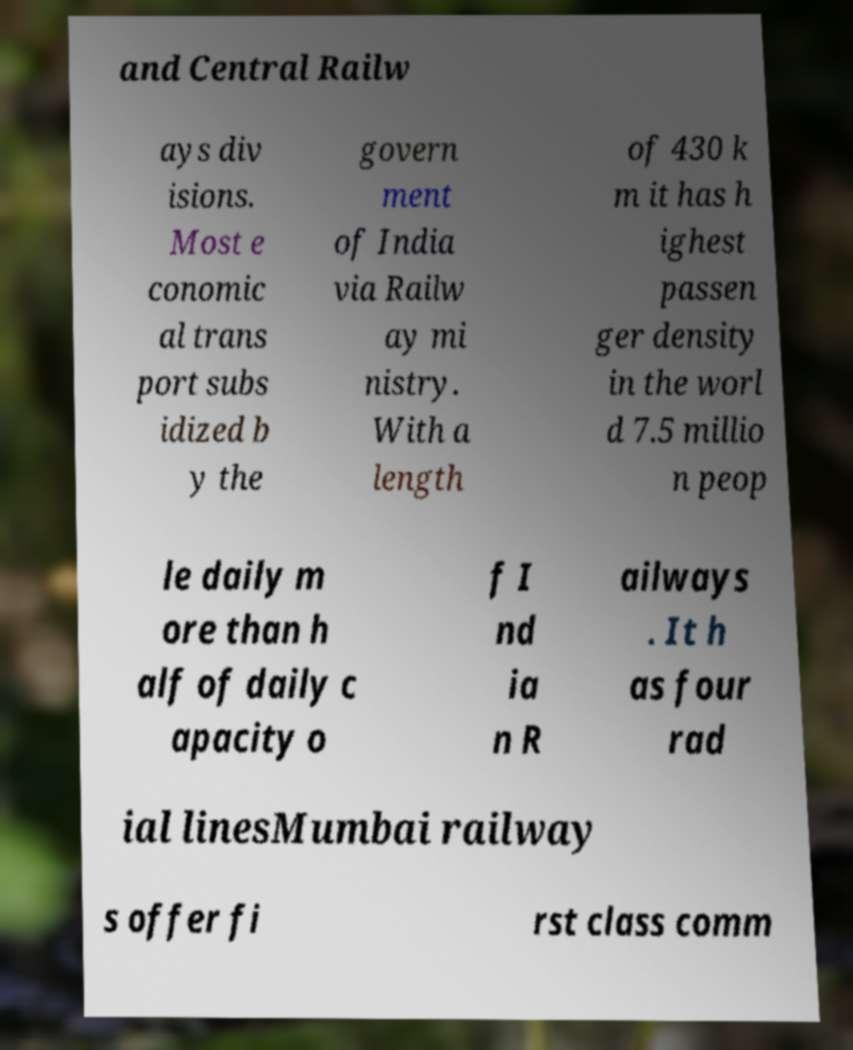Could you assist in decoding the text presented in this image and type it out clearly? and Central Railw ays div isions. Most e conomic al trans port subs idized b y the govern ment of India via Railw ay mi nistry. With a length of 430 k m it has h ighest passen ger density in the worl d 7.5 millio n peop le daily m ore than h alf of daily c apacity o f I nd ia n R ailways . It h as four rad ial linesMumbai railway s offer fi rst class comm 